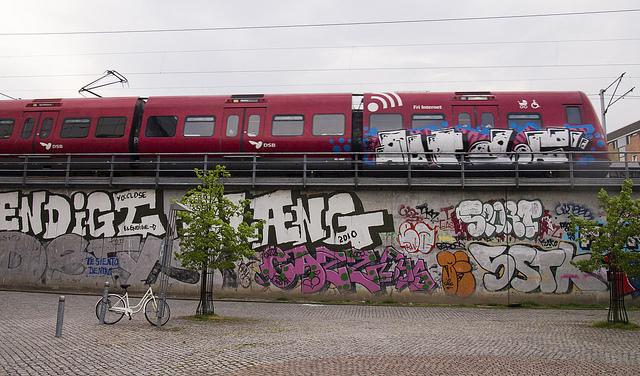What color is the train?
Be succinct. Red. Where is the bike?
Keep it brief. By tree. What is painted on the concrete wall?
Keep it brief. Graffiti. 